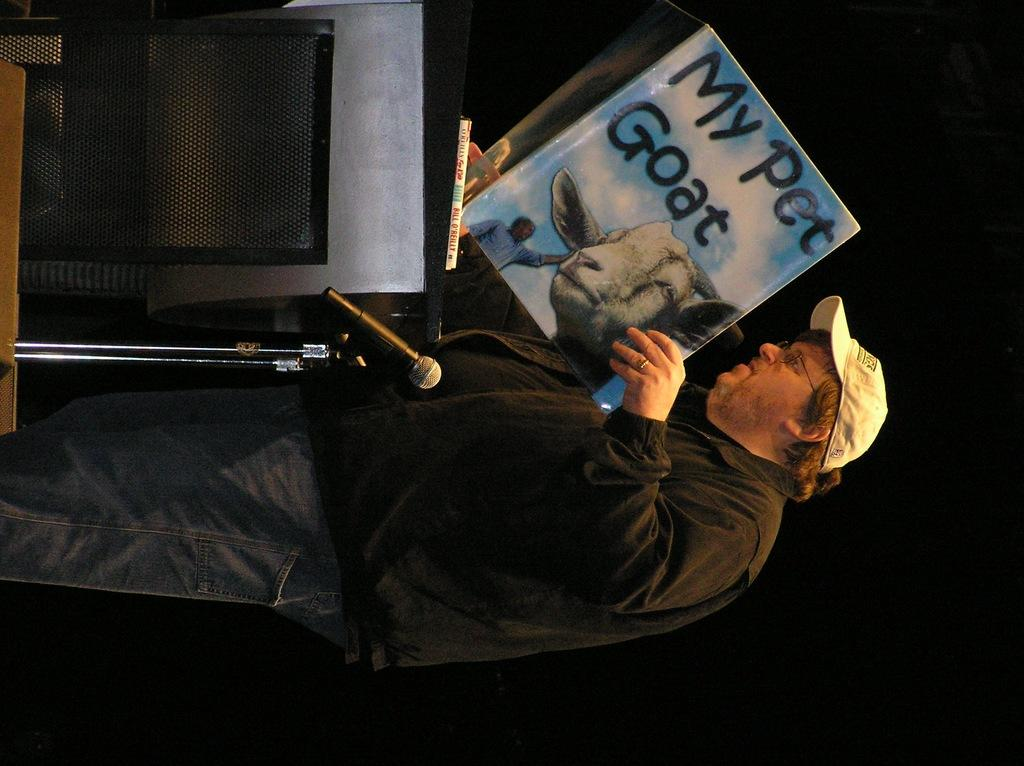<image>
Render a clear and concise summary of the photo. Man holding a book which says "My Pet Goat". 